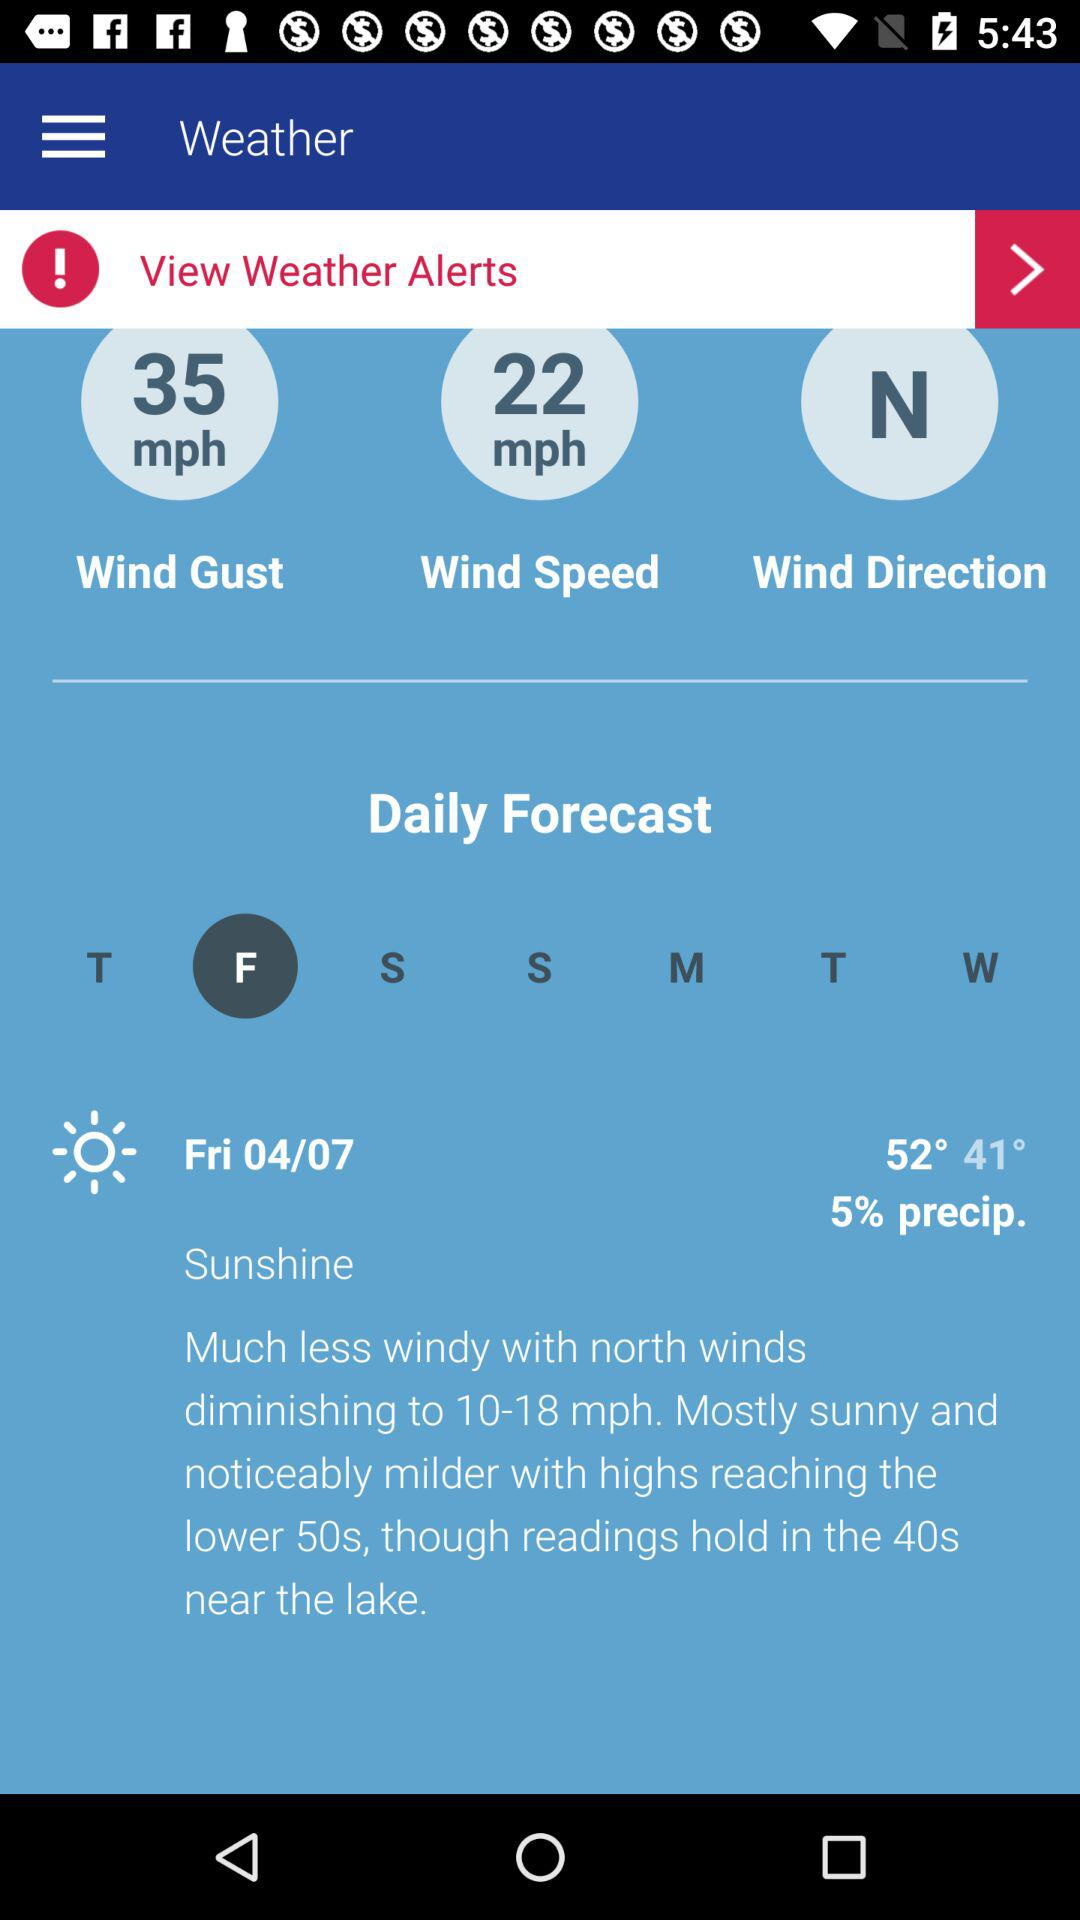Which day's daily forecast is shown? The daily forecast is shown for Friday. 